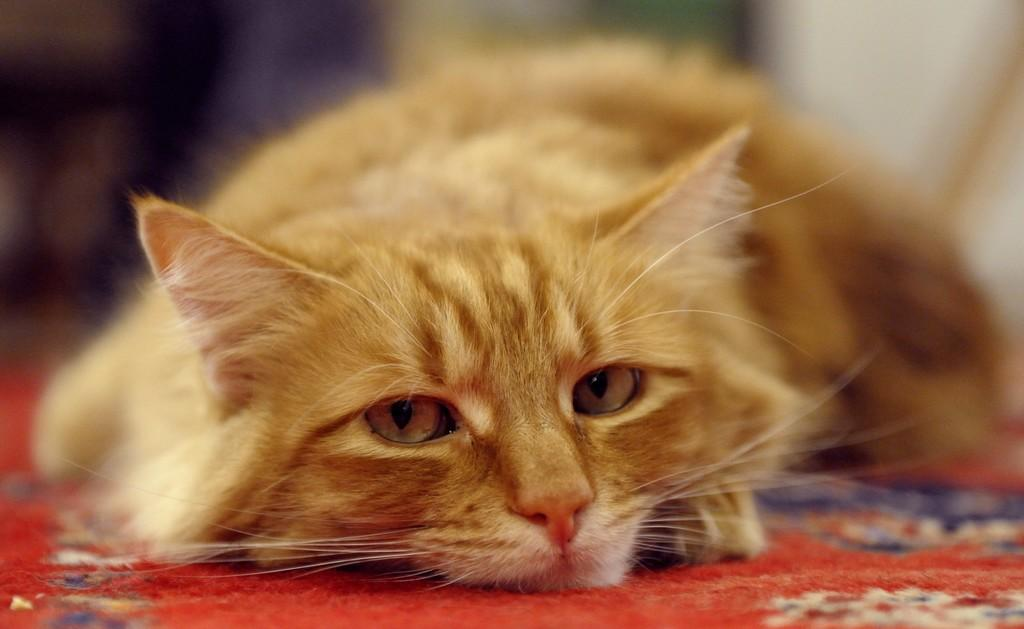What is in the center of the image? There is a carpet in the center of the image. What is on top of the carpet? There is a cat on the carpet. What color is the cat? The cat is brown in color. What type of letter is the cat holding in the image? There is no letter present in the image, as the cat is not holding anything. 